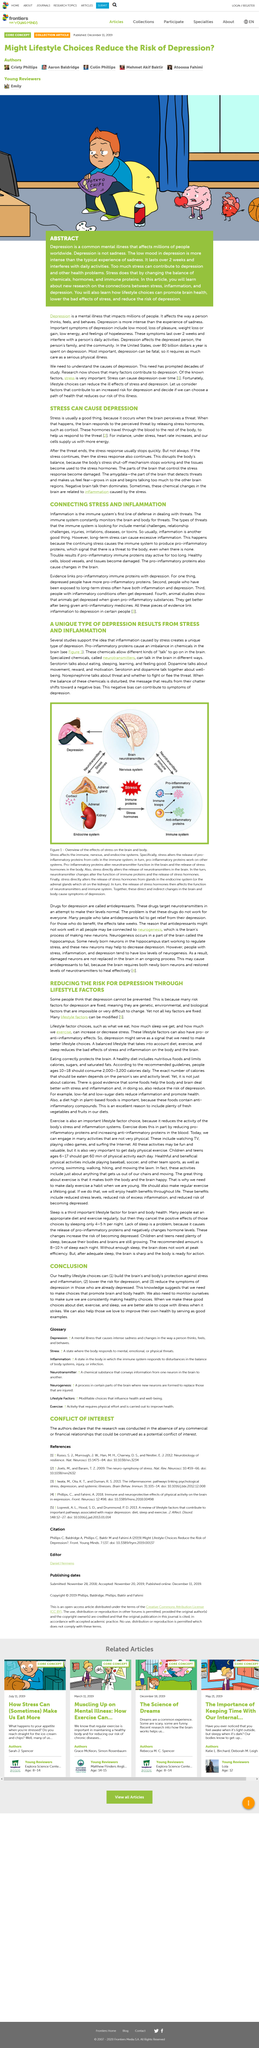Identify some key points in this picture. Depressed individuals have higher levels of pro-inflammatory proteins in their bodies compared to those who are not depressed, according to research. Stress has a significant impact on the immune, nervous, and endocrine systems of the body, leading to a decrease in their functioning and overall health. Long-term stress can lead to inflammation, which is a known contributor to a wide range of health problems. Life style modifications, including physical activity, social interaction, and healthy diet, can effectively prevent depression. Stress can affect the release of pro-inflammatory proteins from cells in the immune system. 